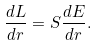<formula> <loc_0><loc_0><loc_500><loc_500>\frac { d L } { d r } = S \frac { d E } { d r } .</formula> 